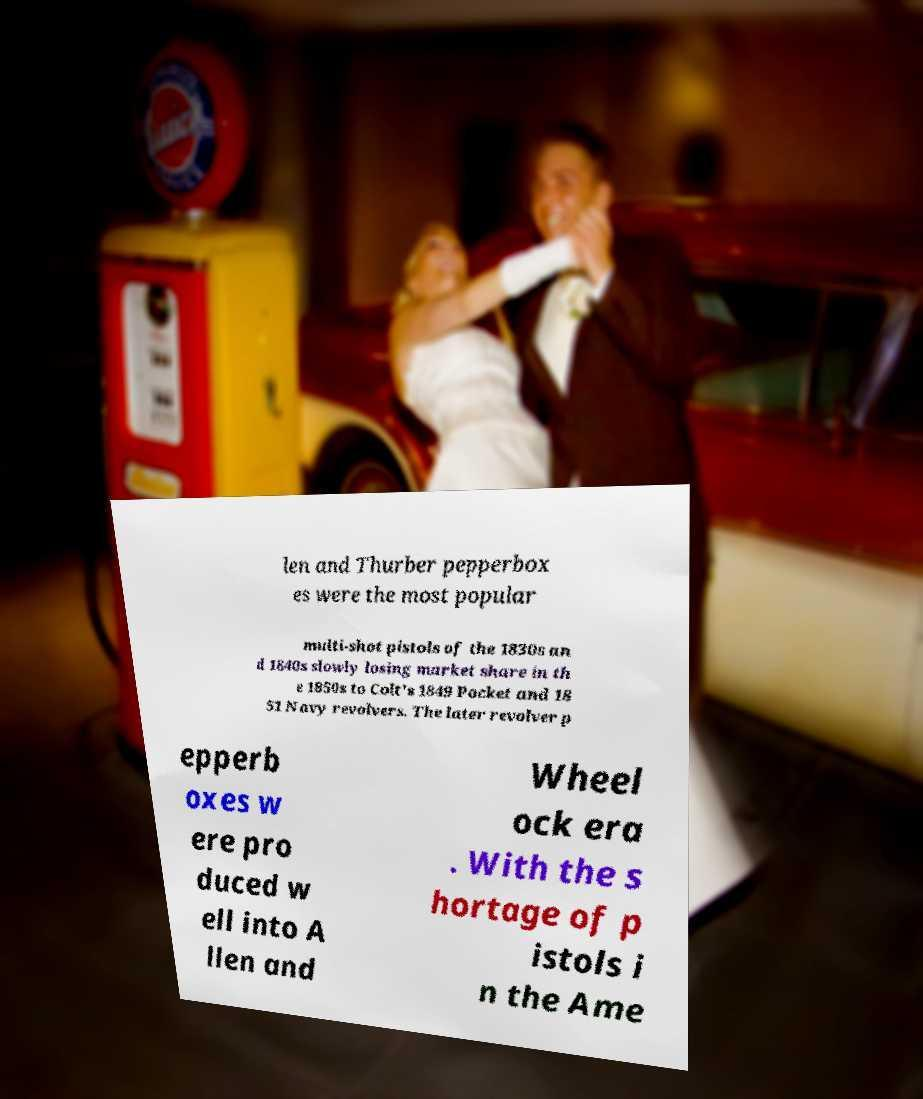There's text embedded in this image that I need extracted. Can you transcribe it verbatim? len and Thurber pepperbox es were the most popular multi-shot pistols of the 1830s an d 1840s slowly losing market share in th e 1850s to Colt's 1849 Pocket and 18 51 Navy revolvers. The later revolver p epperb oxes w ere pro duced w ell into A llen and Wheel ock era . With the s hortage of p istols i n the Ame 